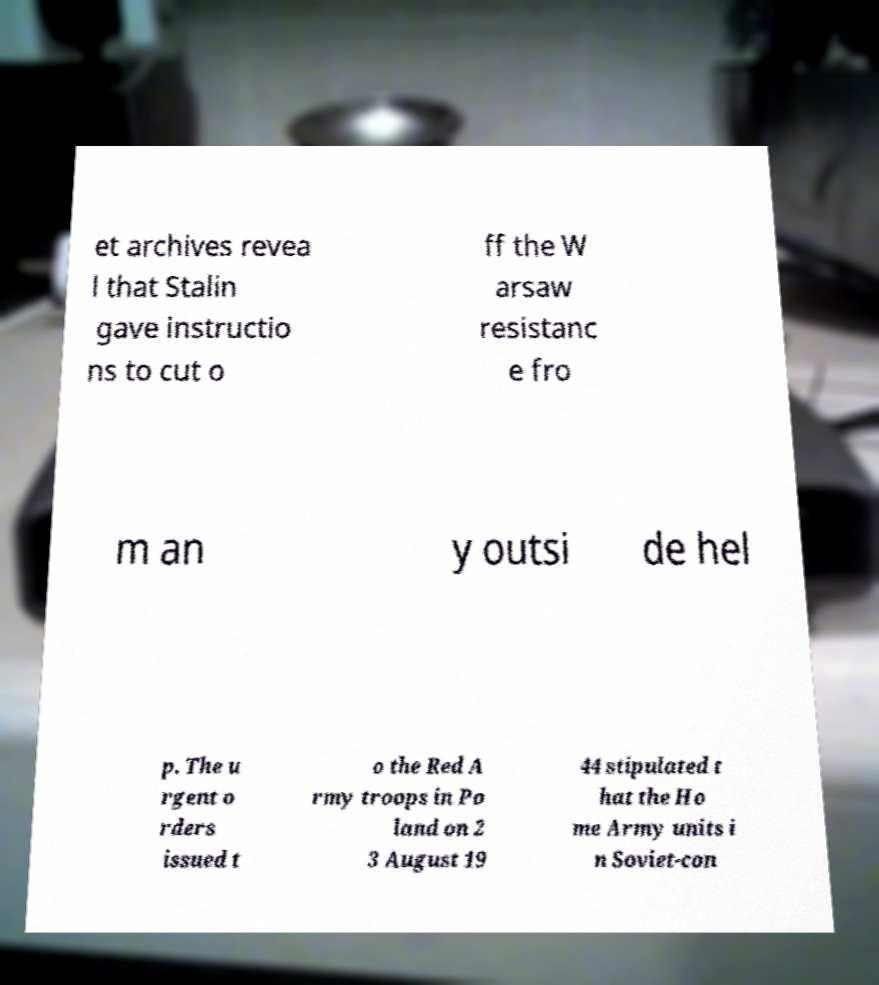Can you read and provide the text displayed in the image?This photo seems to have some interesting text. Can you extract and type it out for me? et archives revea l that Stalin gave instructio ns to cut o ff the W arsaw resistanc e fro m an y outsi de hel p. The u rgent o rders issued t o the Red A rmy troops in Po land on 2 3 August 19 44 stipulated t hat the Ho me Army units i n Soviet-con 